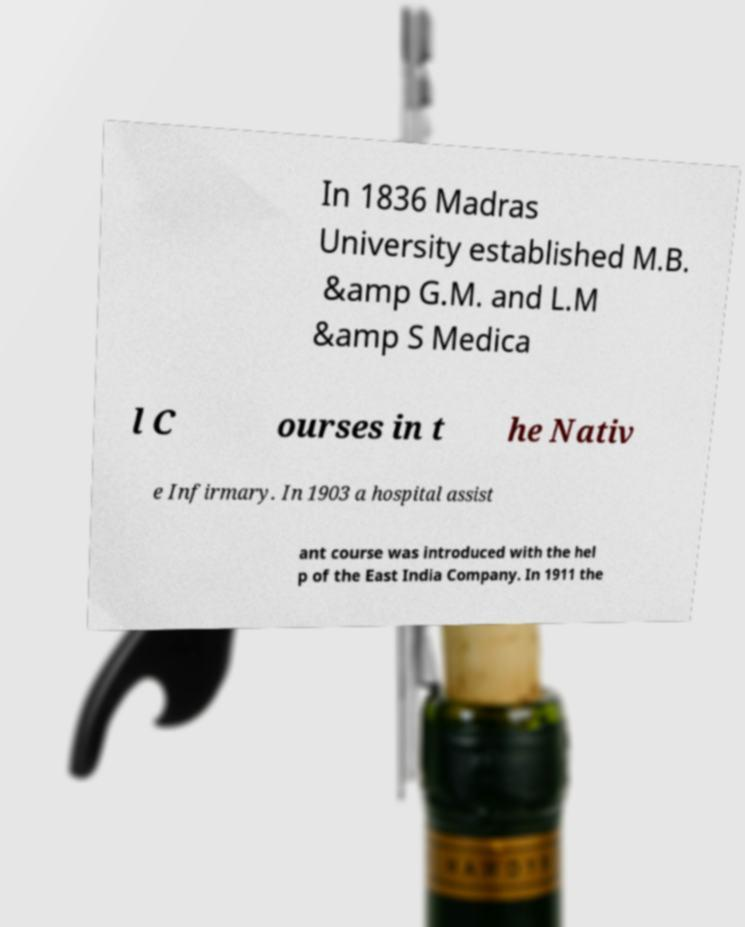For documentation purposes, I need the text within this image transcribed. Could you provide that? In 1836 Madras University established M.B. &amp G.M. and L.M &amp S Medica l C ourses in t he Nativ e Infirmary. In 1903 a hospital assist ant course was introduced with the hel p of the East India Company. In 1911 the 